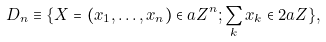Convert formula to latex. <formula><loc_0><loc_0><loc_500><loc_500>D _ { n } \equiv \{ X = ( x _ { 1 } , \dots , x _ { n } ) \in a { Z } ^ { n } ; \sum _ { k } x _ { k } \in 2 a { Z } \} ,</formula> 